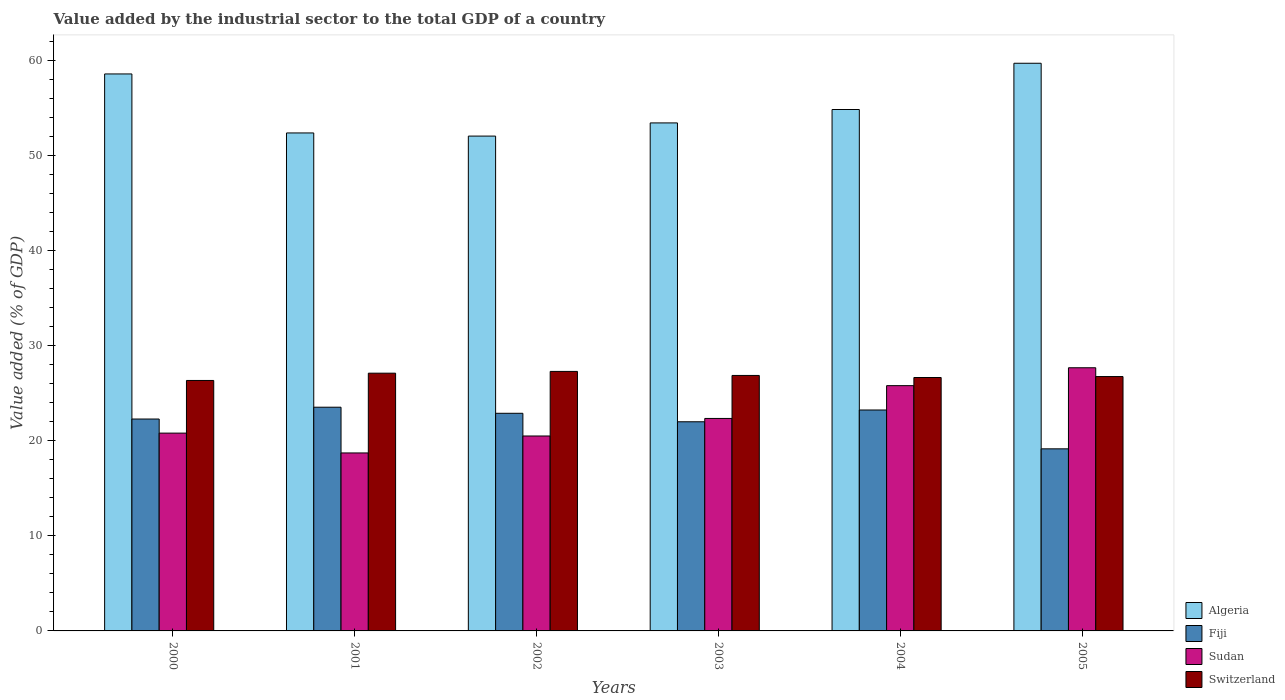How many groups of bars are there?
Your answer should be very brief. 6. Are the number of bars per tick equal to the number of legend labels?
Provide a short and direct response. Yes. What is the label of the 6th group of bars from the left?
Your answer should be very brief. 2005. In how many cases, is the number of bars for a given year not equal to the number of legend labels?
Make the answer very short. 0. What is the value added by the industrial sector to the total GDP in Sudan in 2000?
Ensure brevity in your answer.  20.81. Across all years, what is the maximum value added by the industrial sector to the total GDP in Fiji?
Provide a succinct answer. 23.54. Across all years, what is the minimum value added by the industrial sector to the total GDP in Fiji?
Offer a terse response. 19.16. In which year was the value added by the industrial sector to the total GDP in Sudan maximum?
Give a very brief answer. 2005. What is the total value added by the industrial sector to the total GDP in Algeria in the graph?
Provide a succinct answer. 331.13. What is the difference between the value added by the industrial sector to the total GDP in Sudan in 2001 and that in 2003?
Your response must be concise. -3.63. What is the difference between the value added by the industrial sector to the total GDP in Switzerland in 2000 and the value added by the industrial sector to the total GDP in Fiji in 2005?
Give a very brief answer. 7.19. What is the average value added by the industrial sector to the total GDP in Sudan per year?
Keep it short and to the point. 22.65. In the year 2000, what is the difference between the value added by the industrial sector to the total GDP in Algeria and value added by the industrial sector to the total GDP in Sudan?
Ensure brevity in your answer.  37.79. In how many years, is the value added by the industrial sector to the total GDP in Sudan greater than 60 %?
Give a very brief answer. 0. What is the ratio of the value added by the industrial sector to the total GDP in Sudan in 2003 to that in 2004?
Give a very brief answer. 0.87. Is the value added by the industrial sector to the total GDP in Algeria in 2002 less than that in 2005?
Your answer should be compact. Yes. What is the difference between the highest and the second highest value added by the industrial sector to the total GDP in Switzerland?
Offer a terse response. 0.19. What is the difference between the highest and the lowest value added by the industrial sector to the total GDP in Algeria?
Make the answer very short. 7.66. Is the sum of the value added by the industrial sector to the total GDP in Algeria in 2000 and 2002 greater than the maximum value added by the industrial sector to the total GDP in Switzerland across all years?
Provide a succinct answer. Yes. What does the 3rd bar from the left in 2003 represents?
Provide a short and direct response. Sudan. What does the 1st bar from the right in 2005 represents?
Offer a very short reply. Switzerland. Is it the case that in every year, the sum of the value added by the industrial sector to the total GDP in Sudan and value added by the industrial sector to the total GDP in Fiji is greater than the value added by the industrial sector to the total GDP in Algeria?
Give a very brief answer. No. Are all the bars in the graph horizontal?
Keep it short and to the point. No. What is the difference between two consecutive major ticks on the Y-axis?
Your response must be concise. 10. Where does the legend appear in the graph?
Your answer should be very brief. Bottom right. What is the title of the graph?
Provide a succinct answer. Value added by the industrial sector to the total GDP of a country. What is the label or title of the Y-axis?
Offer a terse response. Value added (% of GDP). What is the Value added (% of GDP) of Algeria in 2000?
Give a very brief answer. 58.61. What is the Value added (% of GDP) in Fiji in 2000?
Offer a very short reply. 22.3. What is the Value added (% of GDP) in Sudan in 2000?
Offer a very short reply. 20.81. What is the Value added (% of GDP) of Switzerland in 2000?
Keep it short and to the point. 26.35. What is the Value added (% of GDP) of Algeria in 2001?
Your answer should be very brief. 52.4. What is the Value added (% of GDP) in Fiji in 2001?
Your answer should be compact. 23.54. What is the Value added (% of GDP) in Sudan in 2001?
Your answer should be very brief. 18.73. What is the Value added (% of GDP) of Switzerland in 2001?
Give a very brief answer. 27.12. What is the Value added (% of GDP) of Algeria in 2002?
Give a very brief answer. 52.07. What is the Value added (% of GDP) in Fiji in 2002?
Give a very brief answer. 22.9. What is the Value added (% of GDP) in Sudan in 2002?
Your response must be concise. 20.51. What is the Value added (% of GDP) in Switzerland in 2002?
Provide a short and direct response. 27.31. What is the Value added (% of GDP) in Algeria in 2003?
Make the answer very short. 53.46. What is the Value added (% of GDP) in Fiji in 2003?
Ensure brevity in your answer.  22.01. What is the Value added (% of GDP) of Sudan in 2003?
Your answer should be very brief. 22.36. What is the Value added (% of GDP) of Switzerland in 2003?
Your answer should be compact. 26.88. What is the Value added (% of GDP) in Algeria in 2004?
Provide a succinct answer. 54.87. What is the Value added (% of GDP) in Fiji in 2004?
Your answer should be very brief. 23.25. What is the Value added (% of GDP) in Sudan in 2004?
Your response must be concise. 25.81. What is the Value added (% of GDP) in Switzerland in 2004?
Offer a very short reply. 26.67. What is the Value added (% of GDP) of Algeria in 2005?
Make the answer very short. 59.73. What is the Value added (% of GDP) in Fiji in 2005?
Provide a succinct answer. 19.16. What is the Value added (% of GDP) of Sudan in 2005?
Your answer should be very brief. 27.69. What is the Value added (% of GDP) of Switzerland in 2005?
Keep it short and to the point. 26.76. Across all years, what is the maximum Value added (% of GDP) of Algeria?
Provide a succinct answer. 59.73. Across all years, what is the maximum Value added (% of GDP) of Fiji?
Provide a succinct answer. 23.54. Across all years, what is the maximum Value added (% of GDP) of Sudan?
Make the answer very short. 27.69. Across all years, what is the maximum Value added (% of GDP) in Switzerland?
Your response must be concise. 27.31. Across all years, what is the minimum Value added (% of GDP) of Algeria?
Provide a succinct answer. 52.07. Across all years, what is the minimum Value added (% of GDP) of Fiji?
Make the answer very short. 19.16. Across all years, what is the minimum Value added (% of GDP) of Sudan?
Offer a very short reply. 18.73. Across all years, what is the minimum Value added (% of GDP) of Switzerland?
Give a very brief answer. 26.35. What is the total Value added (% of GDP) in Algeria in the graph?
Offer a terse response. 331.13. What is the total Value added (% of GDP) of Fiji in the graph?
Make the answer very short. 133.15. What is the total Value added (% of GDP) in Sudan in the graph?
Give a very brief answer. 135.91. What is the total Value added (% of GDP) in Switzerland in the graph?
Your answer should be compact. 161.09. What is the difference between the Value added (% of GDP) of Algeria in 2000 and that in 2001?
Ensure brevity in your answer.  6.21. What is the difference between the Value added (% of GDP) in Fiji in 2000 and that in 2001?
Provide a short and direct response. -1.24. What is the difference between the Value added (% of GDP) of Sudan in 2000 and that in 2001?
Provide a succinct answer. 2.09. What is the difference between the Value added (% of GDP) in Switzerland in 2000 and that in 2001?
Your answer should be compact. -0.77. What is the difference between the Value added (% of GDP) of Algeria in 2000 and that in 2002?
Your answer should be very brief. 6.54. What is the difference between the Value added (% of GDP) of Fiji in 2000 and that in 2002?
Your answer should be very brief. -0.6. What is the difference between the Value added (% of GDP) in Sudan in 2000 and that in 2002?
Provide a succinct answer. 0.3. What is the difference between the Value added (% of GDP) of Switzerland in 2000 and that in 2002?
Provide a short and direct response. -0.95. What is the difference between the Value added (% of GDP) of Algeria in 2000 and that in 2003?
Your answer should be very brief. 5.15. What is the difference between the Value added (% of GDP) of Fiji in 2000 and that in 2003?
Give a very brief answer. 0.29. What is the difference between the Value added (% of GDP) of Sudan in 2000 and that in 2003?
Your answer should be compact. -1.54. What is the difference between the Value added (% of GDP) of Switzerland in 2000 and that in 2003?
Give a very brief answer. -0.53. What is the difference between the Value added (% of GDP) of Algeria in 2000 and that in 2004?
Offer a terse response. 3.74. What is the difference between the Value added (% of GDP) of Fiji in 2000 and that in 2004?
Provide a short and direct response. -0.95. What is the difference between the Value added (% of GDP) in Sudan in 2000 and that in 2004?
Offer a terse response. -4.99. What is the difference between the Value added (% of GDP) of Switzerland in 2000 and that in 2004?
Ensure brevity in your answer.  -0.31. What is the difference between the Value added (% of GDP) of Algeria in 2000 and that in 2005?
Provide a short and direct response. -1.13. What is the difference between the Value added (% of GDP) of Fiji in 2000 and that in 2005?
Ensure brevity in your answer.  3.14. What is the difference between the Value added (% of GDP) in Sudan in 2000 and that in 2005?
Your response must be concise. -6.88. What is the difference between the Value added (% of GDP) of Switzerland in 2000 and that in 2005?
Your answer should be compact. -0.41. What is the difference between the Value added (% of GDP) of Algeria in 2001 and that in 2002?
Your answer should be compact. 0.33. What is the difference between the Value added (% of GDP) of Fiji in 2001 and that in 2002?
Offer a very short reply. 0.64. What is the difference between the Value added (% of GDP) of Sudan in 2001 and that in 2002?
Offer a very short reply. -1.78. What is the difference between the Value added (% of GDP) in Switzerland in 2001 and that in 2002?
Keep it short and to the point. -0.19. What is the difference between the Value added (% of GDP) of Algeria in 2001 and that in 2003?
Keep it short and to the point. -1.06. What is the difference between the Value added (% of GDP) of Fiji in 2001 and that in 2003?
Make the answer very short. 1.53. What is the difference between the Value added (% of GDP) in Sudan in 2001 and that in 2003?
Your answer should be very brief. -3.63. What is the difference between the Value added (% of GDP) in Switzerland in 2001 and that in 2003?
Give a very brief answer. 0.24. What is the difference between the Value added (% of GDP) in Algeria in 2001 and that in 2004?
Offer a terse response. -2.47. What is the difference between the Value added (% of GDP) of Fiji in 2001 and that in 2004?
Your response must be concise. 0.29. What is the difference between the Value added (% of GDP) of Sudan in 2001 and that in 2004?
Your answer should be compact. -7.08. What is the difference between the Value added (% of GDP) in Switzerland in 2001 and that in 2004?
Your answer should be very brief. 0.45. What is the difference between the Value added (% of GDP) of Algeria in 2001 and that in 2005?
Offer a terse response. -7.33. What is the difference between the Value added (% of GDP) of Fiji in 2001 and that in 2005?
Your answer should be very brief. 4.38. What is the difference between the Value added (% of GDP) of Sudan in 2001 and that in 2005?
Offer a very short reply. -8.96. What is the difference between the Value added (% of GDP) in Switzerland in 2001 and that in 2005?
Provide a short and direct response. 0.36. What is the difference between the Value added (% of GDP) in Algeria in 2002 and that in 2003?
Make the answer very short. -1.39. What is the difference between the Value added (% of GDP) in Fiji in 2002 and that in 2003?
Make the answer very short. 0.89. What is the difference between the Value added (% of GDP) in Sudan in 2002 and that in 2003?
Ensure brevity in your answer.  -1.85. What is the difference between the Value added (% of GDP) in Switzerland in 2002 and that in 2003?
Give a very brief answer. 0.42. What is the difference between the Value added (% of GDP) of Algeria in 2002 and that in 2004?
Offer a very short reply. -2.8. What is the difference between the Value added (% of GDP) in Fiji in 2002 and that in 2004?
Your answer should be compact. -0.35. What is the difference between the Value added (% of GDP) in Sudan in 2002 and that in 2004?
Make the answer very short. -5.3. What is the difference between the Value added (% of GDP) of Switzerland in 2002 and that in 2004?
Give a very brief answer. 0.64. What is the difference between the Value added (% of GDP) of Algeria in 2002 and that in 2005?
Provide a short and direct response. -7.66. What is the difference between the Value added (% of GDP) in Fiji in 2002 and that in 2005?
Offer a very short reply. 3.74. What is the difference between the Value added (% of GDP) of Sudan in 2002 and that in 2005?
Offer a terse response. -7.18. What is the difference between the Value added (% of GDP) in Switzerland in 2002 and that in 2005?
Provide a succinct answer. 0.54. What is the difference between the Value added (% of GDP) in Algeria in 2003 and that in 2004?
Keep it short and to the point. -1.41. What is the difference between the Value added (% of GDP) of Fiji in 2003 and that in 2004?
Provide a succinct answer. -1.24. What is the difference between the Value added (% of GDP) in Sudan in 2003 and that in 2004?
Offer a terse response. -3.45. What is the difference between the Value added (% of GDP) of Switzerland in 2003 and that in 2004?
Your response must be concise. 0.22. What is the difference between the Value added (% of GDP) of Algeria in 2003 and that in 2005?
Provide a short and direct response. -6.28. What is the difference between the Value added (% of GDP) in Fiji in 2003 and that in 2005?
Offer a very short reply. 2.85. What is the difference between the Value added (% of GDP) in Sudan in 2003 and that in 2005?
Your answer should be compact. -5.33. What is the difference between the Value added (% of GDP) in Switzerland in 2003 and that in 2005?
Provide a short and direct response. 0.12. What is the difference between the Value added (% of GDP) in Algeria in 2004 and that in 2005?
Keep it short and to the point. -4.87. What is the difference between the Value added (% of GDP) in Fiji in 2004 and that in 2005?
Your answer should be compact. 4.09. What is the difference between the Value added (% of GDP) of Sudan in 2004 and that in 2005?
Offer a terse response. -1.88. What is the difference between the Value added (% of GDP) of Switzerland in 2004 and that in 2005?
Provide a succinct answer. -0.1. What is the difference between the Value added (% of GDP) in Algeria in 2000 and the Value added (% of GDP) in Fiji in 2001?
Give a very brief answer. 35.07. What is the difference between the Value added (% of GDP) of Algeria in 2000 and the Value added (% of GDP) of Sudan in 2001?
Offer a very short reply. 39.88. What is the difference between the Value added (% of GDP) in Algeria in 2000 and the Value added (% of GDP) in Switzerland in 2001?
Your response must be concise. 31.49. What is the difference between the Value added (% of GDP) in Fiji in 2000 and the Value added (% of GDP) in Sudan in 2001?
Your answer should be compact. 3.57. What is the difference between the Value added (% of GDP) of Fiji in 2000 and the Value added (% of GDP) of Switzerland in 2001?
Provide a succinct answer. -4.82. What is the difference between the Value added (% of GDP) in Sudan in 2000 and the Value added (% of GDP) in Switzerland in 2001?
Offer a very short reply. -6.31. What is the difference between the Value added (% of GDP) of Algeria in 2000 and the Value added (% of GDP) of Fiji in 2002?
Give a very brief answer. 35.71. What is the difference between the Value added (% of GDP) in Algeria in 2000 and the Value added (% of GDP) in Sudan in 2002?
Make the answer very short. 38.09. What is the difference between the Value added (% of GDP) in Algeria in 2000 and the Value added (% of GDP) in Switzerland in 2002?
Offer a very short reply. 31.3. What is the difference between the Value added (% of GDP) of Fiji in 2000 and the Value added (% of GDP) of Sudan in 2002?
Offer a terse response. 1.79. What is the difference between the Value added (% of GDP) in Fiji in 2000 and the Value added (% of GDP) in Switzerland in 2002?
Offer a very short reply. -5.01. What is the difference between the Value added (% of GDP) in Sudan in 2000 and the Value added (% of GDP) in Switzerland in 2002?
Give a very brief answer. -6.49. What is the difference between the Value added (% of GDP) in Algeria in 2000 and the Value added (% of GDP) in Fiji in 2003?
Your answer should be compact. 36.6. What is the difference between the Value added (% of GDP) of Algeria in 2000 and the Value added (% of GDP) of Sudan in 2003?
Your response must be concise. 36.25. What is the difference between the Value added (% of GDP) in Algeria in 2000 and the Value added (% of GDP) in Switzerland in 2003?
Offer a very short reply. 31.72. What is the difference between the Value added (% of GDP) in Fiji in 2000 and the Value added (% of GDP) in Sudan in 2003?
Offer a very short reply. -0.06. What is the difference between the Value added (% of GDP) of Fiji in 2000 and the Value added (% of GDP) of Switzerland in 2003?
Keep it short and to the point. -4.59. What is the difference between the Value added (% of GDP) of Sudan in 2000 and the Value added (% of GDP) of Switzerland in 2003?
Offer a very short reply. -6.07. What is the difference between the Value added (% of GDP) in Algeria in 2000 and the Value added (% of GDP) in Fiji in 2004?
Your response must be concise. 35.36. What is the difference between the Value added (% of GDP) in Algeria in 2000 and the Value added (% of GDP) in Sudan in 2004?
Your answer should be very brief. 32.8. What is the difference between the Value added (% of GDP) in Algeria in 2000 and the Value added (% of GDP) in Switzerland in 2004?
Provide a short and direct response. 31.94. What is the difference between the Value added (% of GDP) in Fiji in 2000 and the Value added (% of GDP) in Sudan in 2004?
Your answer should be compact. -3.51. What is the difference between the Value added (% of GDP) in Fiji in 2000 and the Value added (% of GDP) in Switzerland in 2004?
Your response must be concise. -4.37. What is the difference between the Value added (% of GDP) of Sudan in 2000 and the Value added (% of GDP) of Switzerland in 2004?
Ensure brevity in your answer.  -5.85. What is the difference between the Value added (% of GDP) of Algeria in 2000 and the Value added (% of GDP) of Fiji in 2005?
Your response must be concise. 39.45. What is the difference between the Value added (% of GDP) of Algeria in 2000 and the Value added (% of GDP) of Sudan in 2005?
Make the answer very short. 30.92. What is the difference between the Value added (% of GDP) in Algeria in 2000 and the Value added (% of GDP) in Switzerland in 2005?
Ensure brevity in your answer.  31.84. What is the difference between the Value added (% of GDP) in Fiji in 2000 and the Value added (% of GDP) in Sudan in 2005?
Offer a very short reply. -5.39. What is the difference between the Value added (% of GDP) in Fiji in 2000 and the Value added (% of GDP) in Switzerland in 2005?
Keep it short and to the point. -4.47. What is the difference between the Value added (% of GDP) of Sudan in 2000 and the Value added (% of GDP) of Switzerland in 2005?
Your answer should be compact. -5.95. What is the difference between the Value added (% of GDP) in Algeria in 2001 and the Value added (% of GDP) in Fiji in 2002?
Your response must be concise. 29.5. What is the difference between the Value added (% of GDP) of Algeria in 2001 and the Value added (% of GDP) of Sudan in 2002?
Give a very brief answer. 31.89. What is the difference between the Value added (% of GDP) in Algeria in 2001 and the Value added (% of GDP) in Switzerland in 2002?
Offer a terse response. 25.09. What is the difference between the Value added (% of GDP) in Fiji in 2001 and the Value added (% of GDP) in Sudan in 2002?
Ensure brevity in your answer.  3.03. What is the difference between the Value added (% of GDP) in Fiji in 2001 and the Value added (% of GDP) in Switzerland in 2002?
Your answer should be compact. -3.77. What is the difference between the Value added (% of GDP) in Sudan in 2001 and the Value added (% of GDP) in Switzerland in 2002?
Ensure brevity in your answer.  -8.58. What is the difference between the Value added (% of GDP) in Algeria in 2001 and the Value added (% of GDP) in Fiji in 2003?
Offer a terse response. 30.39. What is the difference between the Value added (% of GDP) in Algeria in 2001 and the Value added (% of GDP) in Sudan in 2003?
Your answer should be very brief. 30.04. What is the difference between the Value added (% of GDP) in Algeria in 2001 and the Value added (% of GDP) in Switzerland in 2003?
Offer a terse response. 25.52. What is the difference between the Value added (% of GDP) of Fiji in 2001 and the Value added (% of GDP) of Sudan in 2003?
Provide a succinct answer. 1.18. What is the difference between the Value added (% of GDP) of Fiji in 2001 and the Value added (% of GDP) of Switzerland in 2003?
Provide a short and direct response. -3.34. What is the difference between the Value added (% of GDP) of Sudan in 2001 and the Value added (% of GDP) of Switzerland in 2003?
Provide a short and direct response. -8.15. What is the difference between the Value added (% of GDP) in Algeria in 2001 and the Value added (% of GDP) in Fiji in 2004?
Offer a very short reply. 29.15. What is the difference between the Value added (% of GDP) in Algeria in 2001 and the Value added (% of GDP) in Sudan in 2004?
Your response must be concise. 26.59. What is the difference between the Value added (% of GDP) in Algeria in 2001 and the Value added (% of GDP) in Switzerland in 2004?
Offer a terse response. 25.73. What is the difference between the Value added (% of GDP) of Fiji in 2001 and the Value added (% of GDP) of Sudan in 2004?
Make the answer very short. -2.27. What is the difference between the Value added (% of GDP) in Fiji in 2001 and the Value added (% of GDP) in Switzerland in 2004?
Ensure brevity in your answer.  -3.13. What is the difference between the Value added (% of GDP) of Sudan in 2001 and the Value added (% of GDP) of Switzerland in 2004?
Offer a very short reply. -7.94. What is the difference between the Value added (% of GDP) in Algeria in 2001 and the Value added (% of GDP) in Fiji in 2005?
Keep it short and to the point. 33.24. What is the difference between the Value added (% of GDP) in Algeria in 2001 and the Value added (% of GDP) in Sudan in 2005?
Offer a terse response. 24.71. What is the difference between the Value added (% of GDP) of Algeria in 2001 and the Value added (% of GDP) of Switzerland in 2005?
Provide a short and direct response. 25.63. What is the difference between the Value added (% of GDP) of Fiji in 2001 and the Value added (% of GDP) of Sudan in 2005?
Your response must be concise. -4.15. What is the difference between the Value added (% of GDP) of Fiji in 2001 and the Value added (% of GDP) of Switzerland in 2005?
Ensure brevity in your answer.  -3.22. What is the difference between the Value added (% of GDP) of Sudan in 2001 and the Value added (% of GDP) of Switzerland in 2005?
Your answer should be compact. -8.04. What is the difference between the Value added (% of GDP) in Algeria in 2002 and the Value added (% of GDP) in Fiji in 2003?
Make the answer very short. 30.06. What is the difference between the Value added (% of GDP) of Algeria in 2002 and the Value added (% of GDP) of Sudan in 2003?
Provide a short and direct response. 29.71. What is the difference between the Value added (% of GDP) in Algeria in 2002 and the Value added (% of GDP) in Switzerland in 2003?
Your response must be concise. 25.19. What is the difference between the Value added (% of GDP) of Fiji in 2002 and the Value added (% of GDP) of Sudan in 2003?
Your answer should be compact. 0.54. What is the difference between the Value added (% of GDP) in Fiji in 2002 and the Value added (% of GDP) in Switzerland in 2003?
Make the answer very short. -3.98. What is the difference between the Value added (% of GDP) of Sudan in 2002 and the Value added (% of GDP) of Switzerland in 2003?
Provide a succinct answer. -6.37. What is the difference between the Value added (% of GDP) in Algeria in 2002 and the Value added (% of GDP) in Fiji in 2004?
Ensure brevity in your answer.  28.82. What is the difference between the Value added (% of GDP) of Algeria in 2002 and the Value added (% of GDP) of Sudan in 2004?
Ensure brevity in your answer.  26.26. What is the difference between the Value added (% of GDP) in Algeria in 2002 and the Value added (% of GDP) in Switzerland in 2004?
Your response must be concise. 25.4. What is the difference between the Value added (% of GDP) in Fiji in 2002 and the Value added (% of GDP) in Sudan in 2004?
Provide a succinct answer. -2.91. What is the difference between the Value added (% of GDP) of Fiji in 2002 and the Value added (% of GDP) of Switzerland in 2004?
Give a very brief answer. -3.77. What is the difference between the Value added (% of GDP) in Sudan in 2002 and the Value added (% of GDP) in Switzerland in 2004?
Your answer should be compact. -6.15. What is the difference between the Value added (% of GDP) in Algeria in 2002 and the Value added (% of GDP) in Fiji in 2005?
Offer a very short reply. 32.91. What is the difference between the Value added (% of GDP) in Algeria in 2002 and the Value added (% of GDP) in Sudan in 2005?
Your response must be concise. 24.38. What is the difference between the Value added (% of GDP) in Algeria in 2002 and the Value added (% of GDP) in Switzerland in 2005?
Make the answer very short. 25.3. What is the difference between the Value added (% of GDP) of Fiji in 2002 and the Value added (% of GDP) of Sudan in 2005?
Keep it short and to the point. -4.79. What is the difference between the Value added (% of GDP) of Fiji in 2002 and the Value added (% of GDP) of Switzerland in 2005?
Keep it short and to the point. -3.86. What is the difference between the Value added (% of GDP) of Sudan in 2002 and the Value added (% of GDP) of Switzerland in 2005?
Give a very brief answer. -6.25. What is the difference between the Value added (% of GDP) in Algeria in 2003 and the Value added (% of GDP) in Fiji in 2004?
Your answer should be very brief. 30.21. What is the difference between the Value added (% of GDP) of Algeria in 2003 and the Value added (% of GDP) of Sudan in 2004?
Offer a terse response. 27.65. What is the difference between the Value added (% of GDP) in Algeria in 2003 and the Value added (% of GDP) in Switzerland in 2004?
Provide a short and direct response. 26.79. What is the difference between the Value added (% of GDP) of Fiji in 2003 and the Value added (% of GDP) of Sudan in 2004?
Make the answer very short. -3.8. What is the difference between the Value added (% of GDP) of Fiji in 2003 and the Value added (% of GDP) of Switzerland in 2004?
Your answer should be very brief. -4.66. What is the difference between the Value added (% of GDP) in Sudan in 2003 and the Value added (% of GDP) in Switzerland in 2004?
Ensure brevity in your answer.  -4.31. What is the difference between the Value added (% of GDP) of Algeria in 2003 and the Value added (% of GDP) of Fiji in 2005?
Keep it short and to the point. 34.3. What is the difference between the Value added (% of GDP) of Algeria in 2003 and the Value added (% of GDP) of Sudan in 2005?
Your answer should be very brief. 25.76. What is the difference between the Value added (% of GDP) of Algeria in 2003 and the Value added (% of GDP) of Switzerland in 2005?
Ensure brevity in your answer.  26.69. What is the difference between the Value added (% of GDP) in Fiji in 2003 and the Value added (% of GDP) in Sudan in 2005?
Give a very brief answer. -5.68. What is the difference between the Value added (% of GDP) of Fiji in 2003 and the Value added (% of GDP) of Switzerland in 2005?
Your response must be concise. -4.76. What is the difference between the Value added (% of GDP) in Sudan in 2003 and the Value added (% of GDP) in Switzerland in 2005?
Provide a succinct answer. -4.41. What is the difference between the Value added (% of GDP) in Algeria in 2004 and the Value added (% of GDP) in Fiji in 2005?
Make the answer very short. 35.7. What is the difference between the Value added (% of GDP) in Algeria in 2004 and the Value added (% of GDP) in Sudan in 2005?
Keep it short and to the point. 27.17. What is the difference between the Value added (% of GDP) in Algeria in 2004 and the Value added (% of GDP) in Switzerland in 2005?
Keep it short and to the point. 28.1. What is the difference between the Value added (% of GDP) of Fiji in 2004 and the Value added (% of GDP) of Sudan in 2005?
Give a very brief answer. -4.44. What is the difference between the Value added (% of GDP) in Fiji in 2004 and the Value added (% of GDP) in Switzerland in 2005?
Provide a short and direct response. -3.52. What is the difference between the Value added (% of GDP) of Sudan in 2004 and the Value added (% of GDP) of Switzerland in 2005?
Your response must be concise. -0.96. What is the average Value added (% of GDP) of Algeria per year?
Offer a terse response. 55.19. What is the average Value added (% of GDP) of Fiji per year?
Ensure brevity in your answer.  22.19. What is the average Value added (% of GDP) in Sudan per year?
Your response must be concise. 22.65. What is the average Value added (% of GDP) in Switzerland per year?
Make the answer very short. 26.85. In the year 2000, what is the difference between the Value added (% of GDP) of Algeria and Value added (% of GDP) of Fiji?
Offer a very short reply. 36.31. In the year 2000, what is the difference between the Value added (% of GDP) in Algeria and Value added (% of GDP) in Sudan?
Your response must be concise. 37.79. In the year 2000, what is the difference between the Value added (% of GDP) in Algeria and Value added (% of GDP) in Switzerland?
Your response must be concise. 32.25. In the year 2000, what is the difference between the Value added (% of GDP) in Fiji and Value added (% of GDP) in Sudan?
Offer a terse response. 1.48. In the year 2000, what is the difference between the Value added (% of GDP) of Fiji and Value added (% of GDP) of Switzerland?
Offer a very short reply. -4.06. In the year 2000, what is the difference between the Value added (% of GDP) of Sudan and Value added (% of GDP) of Switzerland?
Make the answer very short. -5.54. In the year 2001, what is the difference between the Value added (% of GDP) in Algeria and Value added (% of GDP) in Fiji?
Keep it short and to the point. 28.86. In the year 2001, what is the difference between the Value added (% of GDP) in Algeria and Value added (% of GDP) in Sudan?
Provide a succinct answer. 33.67. In the year 2001, what is the difference between the Value added (% of GDP) in Algeria and Value added (% of GDP) in Switzerland?
Provide a succinct answer. 25.28. In the year 2001, what is the difference between the Value added (% of GDP) in Fiji and Value added (% of GDP) in Sudan?
Provide a short and direct response. 4.81. In the year 2001, what is the difference between the Value added (% of GDP) of Fiji and Value added (% of GDP) of Switzerland?
Your answer should be compact. -3.58. In the year 2001, what is the difference between the Value added (% of GDP) of Sudan and Value added (% of GDP) of Switzerland?
Provide a short and direct response. -8.39. In the year 2002, what is the difference between the Value added (% of GDP) of Algeria and Value added (% of GDP) of Fiji?
Your answer should be compact. 29.17. In the year 2002, what is the difference between the Value added (% of GDP) of Algeria and Value added (% of GDP) of Sudan?
Your answer should be compact. 31.56. In the year 2002, what is the difference between the Value added (% of GDP) of Algeria and Value added (% of GDP) of Switzerland?
Your answer should be very brief. 24.76. In the year 2002, what is the difference between the Value added (% of GDP) of Fiji and Value added (% of GDP) of Sudan?
Give a very brief answer. 2.39. In the year 2002, what is the difference between the Value added (% of GDP) in Fiji and Value added (% of GDP) in Switzerland?
Provide a short and direct response. -4.41. In the year 2002, what is the difference between the Value added (% of GDP) of Sudan and Value added (% of GDP) of Switzerland?
Keep it short and to the point. -6.79. In the year 2003, what is the difference between the Value added (% of GDP) in Algeria and Value added (% of GDP) in Fiji?
Your response must be concise. 31.45. In the year 2003, what is the difference between the Value added (% of GDP) in Algeria and Value added (% of GDP) in Sudan?
Ensure brevity in your answer.  31.1. In the year 2003, what is the difference between the Value added (% of GDP) of Algeria and Value added (% of GDP) of Switzerland?
Provide a succinct answer. 26.57. In the year 2003, what is the difference between the Value added (% of GDP) in Fiji and Value added (% of GDP) in Sudan?
Offer a terse response. -0.35. In the year 2003, what is the difference between the Value added (% of GDP) of Fiji and Value added (% of GDP) of Switzerland?
Provide a short and direct response. -4.87. In the year 2003, what is the difference between the Value added (% of GDP) of Sudan and Value added (% of GDP) of Switzerland?
Offer a terse response. -4.52. In the year 2004, what is the difference between the Value added (% of GDP) of Algeria and Value added (% of GDP) of Fiji?
Provide a short and direct response. 31.62. In the year 2004, what is the difference between the Value added (% of GDP) in Algeria and Value added (% of GDP) in Sudan?
Offer a very short reply. 29.06. In the year 2004, what is the difference between the Value added (% of GDP) in Algeria and Value added (% of GDP) in Switzerland?
Give a very brief answer. 28.2. In the year 2004, what is the difference between the Value added (% of GDP) in Fiji and Value added (% of GDP) in Sudan?
Ensure brevity in your answer.  -2.56. In the year 2004, what is the difference between the Value added (% of GDP) in Fiji and Value added (% of GDP) in Switzerland?
Provide a short and direct response. -3.42. In the year 2004, what is the difference between the Value added (% of GDP) in Sudan and Value added (% of GDP) in Switzerland?
Provide a short and direct response. -0.86. In the year 2005, what is the difference between the Value added (% of GDP) of Algeria and Value added (% of GDP) of Fiji?
Provide a succinct answer. 40.57. In the year 2005, what is the difference between the Value added (% of GDP) of Algeria and Value added (% of GDP) of Sudan?
Provide a succinct answer. 32.04. In the year 2005, what is the difference between the Value added (% of GDP) in Algeria and Value added (% of GDP) in Switzerland?
Provide a short and direct response. 32.97. In the year 2005, what is the difference between the Value added (% of GDP) in Fiji and Value added (% of GDP) in Sudan?
Keep it short and to the point. -8.53. In the year 2005, what is the difference between the Value added (% of GDP) of Fiji and Value added (% of GDP) of Switzerland?
Make the answer very short. -7.6. In the year 2005, what is the difference between the Value added (% of GDP) of Sudan and Value added (% of GDP) of Switzerland?
Make the answer very short. 0.93. What is the ratio of the Value added (% of GDP) of Algeria in 2000 to that in 2001?
Your answer should be very brief. 1.12. What is the ratio of the Value added (% of GDP) in Fiji in 2000 to that in 2001?
Your answer should be compact. 0.95. What is the ratio of the Value added (% of GDP) of Sudan in 2000 to that in 2001?
Your response must be concise. 1.11. What is the ratio of the Value added (% of GDP) of Switzerland in 2000 to that in 2001?
Your answer should be very brief. 0.97. What is the ratio of the Value added (% of GDP) in Algeria in 2000 to that in 2002?
Your answer should be compact. 1.13. What is the ratio of the Value added (% of GDP) of Fiji in 2000 to that in 2002?
Offer a very short reply. 0.97. What is the ratio of the Value added (% of GDP) in Sudan in 2000 to that in 2002?
Offer a very short reply. 1.01. What is the ratio of the Value added (% of GDP) in Switzerland in 2000 to that in 2002?
Offer a terse response. 0.97. What is the ratio of the Value added (% of GDP) in Algeria in 2000 to that in 2003?
Your answer should be very brief. 1.1. What is the ratio of the Value added (% of GDP) of Fiji in 2000 to that in 2003?
Your answer should be compact. 1.01. What is the ratio of the Value added (% of GDP) of Switzerland in 2000 to that in 2003?
Your answer should be very brief. 0.98. What is the ratio of the Value added (% of GDP) of Algeria in 2000 to that in 2004?
Provide a short and direct response. 1.07. What is the ratio of the Value added (% of GDP) in Fiji in 2000 to that in 2004?
Keep it short and to the point. 0.96. What is the ratio of the Value added (% of GDP) in Sudan in 2000 to that in 2004?
Provide a short and direct response. 0.81. What is the ratio of the Value added (% of GDP) in Switzerland in 2000 to that in 2004?
Your answer should be compact. 0.99. What is the ratio of the Value added (% of GDP) of Algeria in 2000 to that in 2005?
Ensure brevity in your answer.  0.98. What is the ratio of the Value added (% of GDP) of Fiji in 2000 to that in 2005?
Keep it short and to the point. 1.16. What is the ratio of the Value added (% of GDP) in Sudan in 2000 to that in 2005?
Offer a very short reply. 0.75. What is the ratio of the Value added (% of GDP) of Switzerland in 2000 to that in 2005?
Offer a terse response. 0.98. What is the ratio of the Value added (% of GDP) in Algeria in 2001 to that in 2002?
Your answer should be compact. 1.01. What is the ratio of the Value added (% of GDP) in Fiji in 2001 to that in 2002?
Your answer should be compact. 1.03. What is the ratio of the Value added (% of GDP) of Sudan in 2001 to that in 2002?
Your answer should be very brief. 0.91. What is the ratio of the Value added (% of GDP) in Switzerland in 2001 to that in 2002?
Give a very brief answer. 0.99. What is the ratio of the Value added (% of GDP) in Algeria in 2001 to that in 2003?
Ensure brevity in your answer.  0.98. What is the ratio of the Value added (% of GDP) of Fiji in 2001 to that in 2003?
Make the answer very short. 1.07. What is the ratio of the Value added (% of GDP) in Sudan in 2001 to that in 2003?
Provide a succinct answer. 0.84. What is the ratio of the Value added (% of GDP) in Switzerland in 2001 to that in 2003?
Offer a very short reply. 1.01. What is the ratio of the Value added (% of GDP) in Algeria in 2001 to that in 2004?
Your answer should be compact. 0.96. What is the ratio of the Value added (% of GDP) in Fiji in 2001 to that in 2004?
Offer a terse response. 1.01. What is the ratio of the Value added (% of GDP) of Sudan in 2001 to that in 2004?
Your answer should be very brief. 0.73. What is the ratio of the Value added (% of GDP) of Switzerland in 2001 to that in 2004?
Give a very brief answer. 1.02. What is the ratio of the Value added (% of GDP) of Algeria in 2001 to that in 2005?
Ensure brevity in your answer.  0.88. What is the ratio of the Value added (% of GDP) of Fiji in 2001 to that in 2005?
Offer a very short reply. 1.23. What is the ratio of the Value added (% of GDP) in Sudan in 2001 to that in 2005?
Provide a succinct answer. 0.68. What is the ratio of the Value added (% of GDP) in Switzerland in 2001 to that in 2005?
Make the answer very short. 1.01. What is the ratio of the Value added (% of GDP) of Algeria in 2002 to that in 2003?
Ensure brevity in your answer.  0.97. What is the ratio of the Value added (% of GDP) in Fiji in 2002 to that in 2003?
Your answer should be very brief. 1.04. What is the ratio of the Value added (% of GDP) in Sudan in 2002 to that in 2003?
Ensure brevity in your answer.  0.92. What is the ratio of the Value added (% of GDP) in Switzerland in 2002 to that in 2003?
Keep it short and to the point. 1.02. What is the ratio of the Value added (% of GDP) in Algeria in 2002 to that in 2004?
Your answer should be very brief. 0.95. What is the ratio of the Value added (% of GDP) of Fiji in 2002 to that in 2004?
Ensure brevity in your answer.  0.99. What is the ratio of the Value added (% of GDP) of Sudan in 2002 to that in 2004?
Offer a very short reply. 0.79. What is the ratio of the Value added (% of GDP) of Algeria in 2002 to that in 2005?
Keep it short and to the point. 0.87. What is the ratio of the Value added (% of GDP) in Fiji in 2002 to that in 2005?
Keep it short and to the point. 1.2. What is the ratio of the Value added (% of GDP) in Sudan in 2002 to that in 2005?
Offer a terse response. 0.74. What is the ratio of the Value added (% of GDP) in Switzerland in 2002 to that in 2005?
Provide a succinct answer. 1.02. What is the ratio of the Value added (% of GDP) of Algeria in 2003 to that in 2004?
Offer a very short reply. 0.97. What is the ratio of the Value added (% of GDP) in Fiji in 2003 to that in 2004?
Offer a terse response. 0.95. What is the ratio of the Value added (% of GDP) of Sudan in 2003 to that in 2004?
Your answer should be very brief. 0.87. What is the ratio of the Value added (% of GDP) of Switzerland in 2003 to that in 2004?
Keep it short and to the point. 1.01. What is the ratio of the Value added (% of GDP) of Algeria in 2003 to that in 2005?
Provide a short and direct response. 0.89. What is the ratio of the Value added (% of GDP) of Fiji in 2003 to that in 2005?
Provide a short and direct response. 1.15. What is the ratio of the Value added (% of GDP) of Sudan in 2003 to that in 2005?
Keep it short and to the point. 0.81. What is the ratio of the Value added (% of GDP) in Switzerland in 2003 to that in 2005?
Give a very brief answer. 1. What is the ratio of the Value added (% of GDP) of Algeria in 2004 to that in 2005?
Your answer should be compact. 0.92. What is the ratio of the Value added (% of GDP) in Fiji in 2004 to that in 2005?
Your answer should be very brief. 1.21. What is the ratio of the Value added (% of GDP) of Sudan in 2004 to that in 2005?
Provide a succinct answer. 0.93. What is the ratio of the Value added (% of GDP) in Switzerland in 2004 to that in 2005?
Keep it short and to the point. 1. What is the difference between the highest and the second highest Value added (% of GDP) in Algeria?
Provide a short and direct response. 1.13. What is the difference between the highest and the second highest Value added (% of GDP) of Fiji?
Make the answer very short. 0.29. What is the difference between the highest and the second highest Value added (% of GDP) in Sudan?
Offer a very short reply. 1.88. What is the difference between the highest and the second highest Value added (% of GDP) of Switzerland?
Provide a succinct answer. 0.19. What is the difference between the highest and the lowest Value added (% of GDP) in Algeria?
Offer a terse response. 7.66. What is the difference between the highest and the lowest Value added (% of GDP) of Fiji?
Your response must be concise. 4.38. What is the difference between the highest and the lowest Value added (% of GDP) in Sudan?
Your answer should be very brief. 8.96. What is the difference between the highest and the lowest Value added (% of GDP) in Switzerland?
Provide a succinct answer. 0.95. 